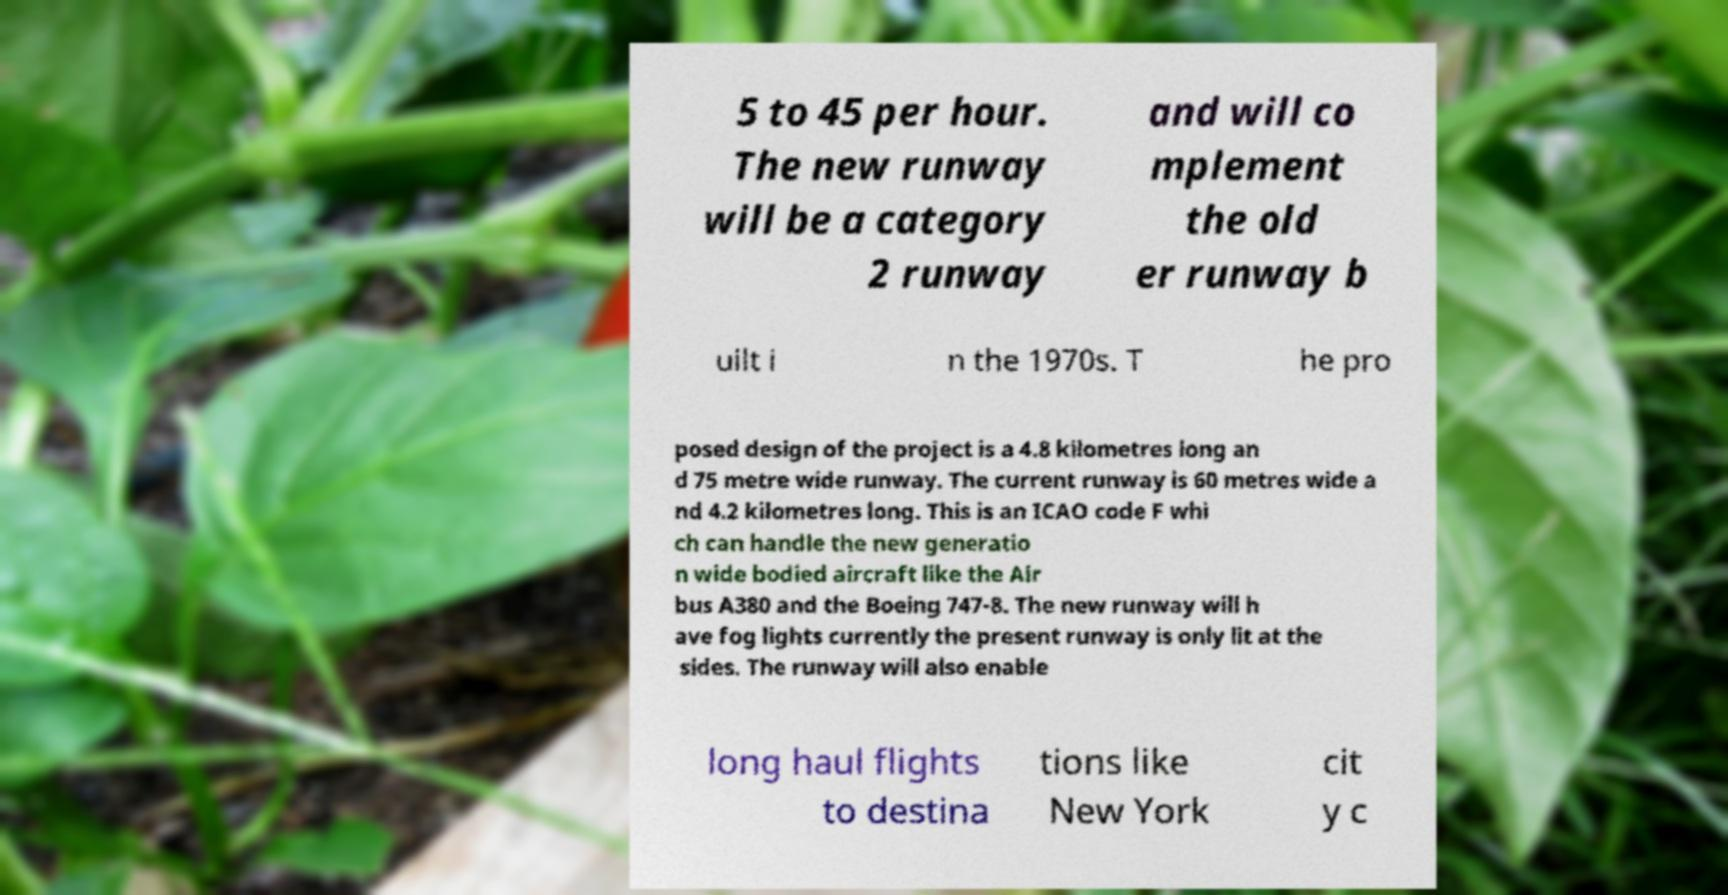Please identify and transcribe the text found in this image. 5 to 45 per hour. The new runway will be a category 2 runway and will co mplement the old er runway b uilt i n the 1970s. T he pro posed design of the project is a 4.8 kilometres long an d 75 metre wide runway. The current runway is 60 metres wide a nd 4.2 kilometres long. This is an ICAO code F whi ch can handle the new generatio n wide bodied aircraft like the Air bus A380 and the Boeing 747-8. The new runway will h ave fog lights currently the present runway is only lit at the sides. The runway will also enable long haul flights to destina tions like New York cit y c 